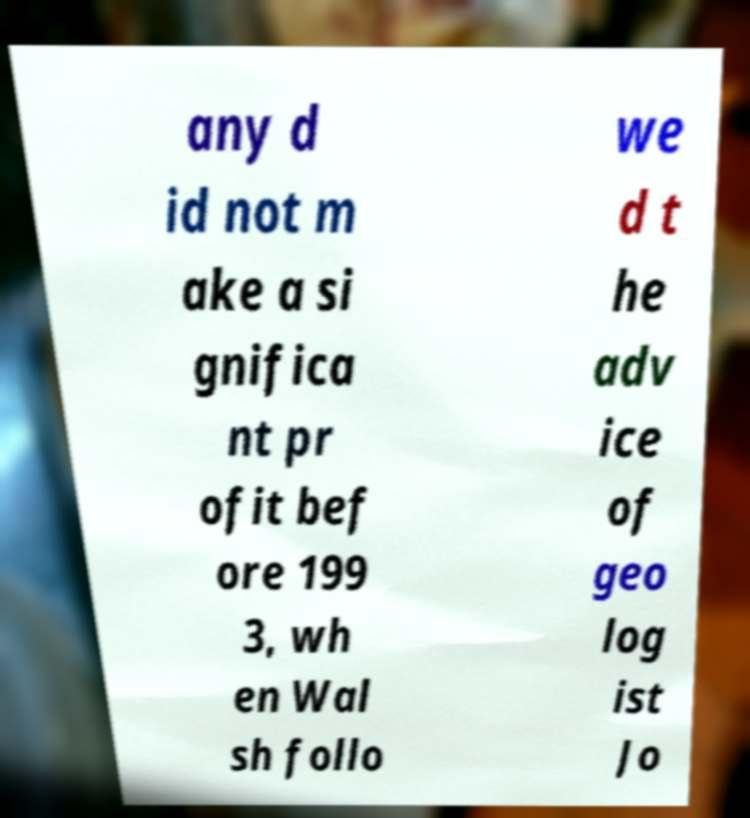Could you assist in decoding the text presented in this image and type it out clearly? any d id not m ake a si gnifica nt pr ofit bef ore 199 3, wh en Wal sh follo we d t he adv ice of geo log ist Jo 